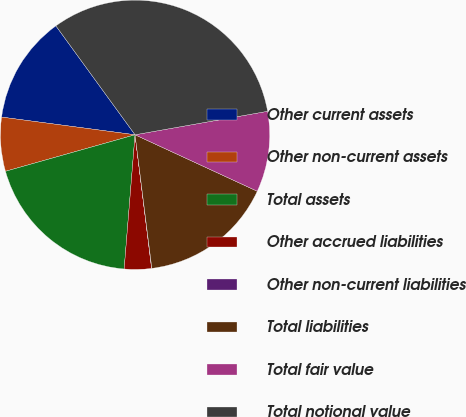Convert chart. <chart><loc_0><loc_0><loc_500><loc_500><pie_chart><fcel>Other current assets<fcel>Other non-current assets<fcel>Total assets<fcel>Other accrued liabilities<fcel>Other non-current liabilities<fcel>Total liabilities<fcel>Total fair value<fcel>Total notional value<nl><fcel>12.9%<fcel>6.47%<fcel>19.34%<fcel>3.25%<fcel>0.03%<fcel>16.12%<fcel>9.68%<fcel>32.21%<nl></chart> 